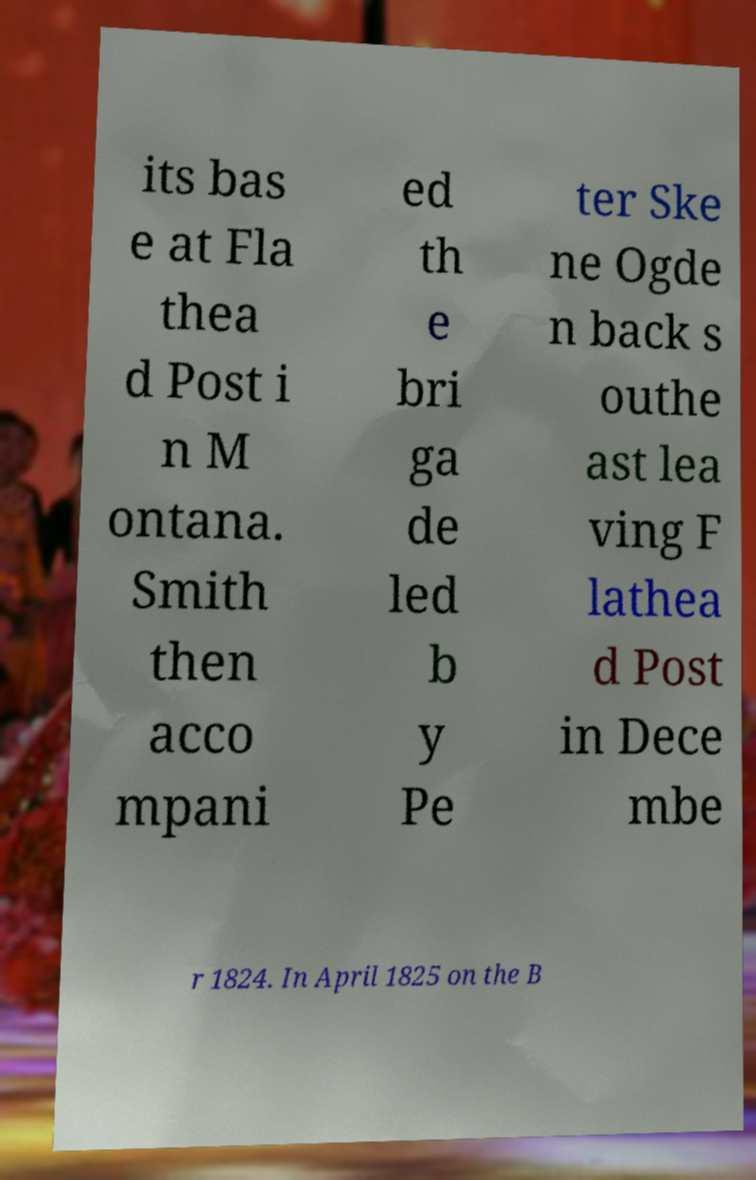I need the written content from this picture converted into text. Can you do that? its bas e at Fla thea d Post i n M ontana. Smith then acco mpani ed th e bri ga de led b y Pe ter Ske ne Ogde n back s outhe ast lea ving F lathea d Post in Dece mbe r 1824. In April 1825 on the B 